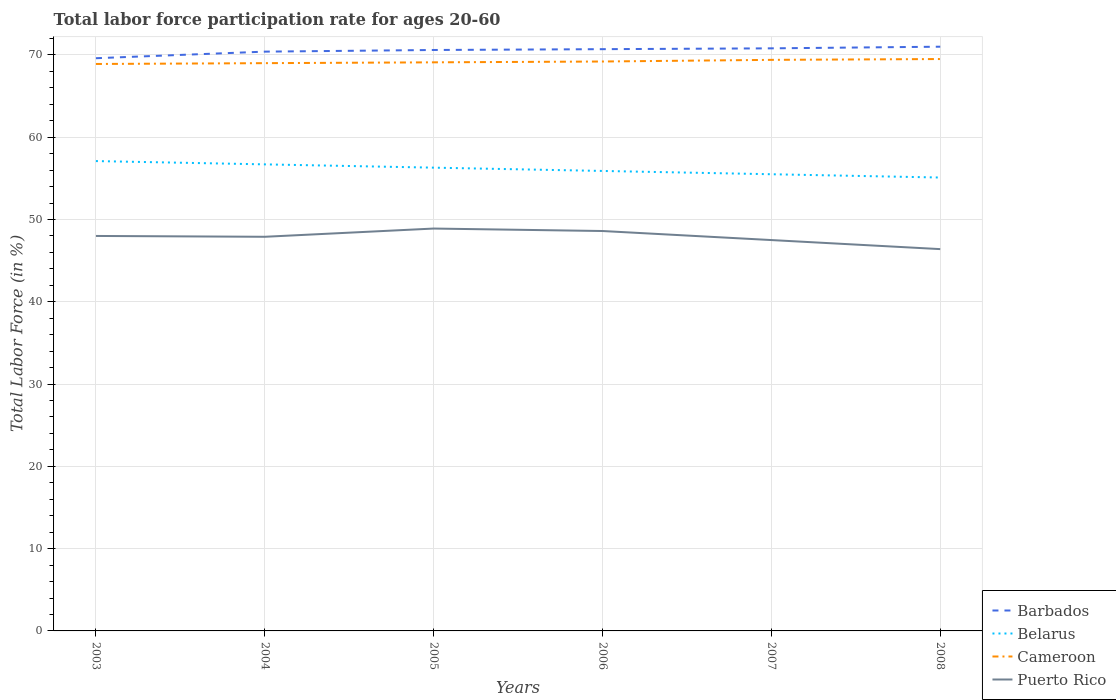Does the line corresponding to Cameroon intersect with the line corresponding to Belarus?
Provide a succinct answer. No. Is the number of lines equal to the number of legend labels?
Keep it short and to the point. Yes. Across all years, what is the maximum labor force participation rate in Belarus?
Offer a terse response. 55.1. What is the total labor force participation rate in Barbados in the graph?
Your response must be concise. -0.2. What is the difference between the highest and the second highest labor force participation rate in Belarus?
Your response must be concise. 2. What is the difference between the highest and the lowest labor force participation rate in Puerto Rico?
Provide a short and direct response. 4. What is the difference between two consecutive major ticks on the Y-axis?
Provide a short and direct response. 10. Does the graph contain any zero values?
Provide a short and direct response. No. Does the graph contain grids?
Provide a succinct answer. Yes. Where does the legend appear in the graph?
Your answer should be compact. Bottom right. How many legend labels are there?
Offer a terse response. 4. How are the legend labels stacked?
Give a very brief answer. Vertical. What is the title of the graph?
Ensure brevity in your answer.  Total labor force participation rate for ages 20-60. Does "High income" appear as one of the legend labels in the graph?
Your response must be concise. No. What is the label or title of the X-axis?
Give a very brief answer. Years. What is the label or title of the Y-axis?
Offer a very short reply. Total Labor Force (in %). What is the Total Labor Force (in %) of Barbados in 2003?
Your response must be concise. 69.6. What is the Total Labor Force (in %) of Belarus in 2003?
Provide a succinct answer. 57.1. What is the Total Labor Force (in %) of Cameroon in 2003?
Ensure brevity in your answer.  68.9. What is the Total Labor Force (in %) in Barbados in 2004?
Ensure brevity in your answer.  70.4. What is the Total Labor Force (in %) of Belarus in 2004?
Your answer should be compact. 56.7. What is the Total Labor Force (in %) of Puerto Rico in 2004?
Your answer should be very brief. 47.9. What is the Total Labor Force (in %) of Barbados in 2005?
Your answer should be very brief. 70.6. What is the Total Labor Force (in %) in Belarus in 2005?
Offer a terse response. 56.3. What is the Total Labor Force (in %) in Cameroon in 2005?
Your answer should be compact. 69.1. What is the Total Labor Force (in %) of Puerto Rico in 2005?
Ensure brevity in your answer.  48.9. What is the Total Labor Force (in %) of Barbados in 2006?
Ensure brevity in your answer.  70.7. What is the Total Labor Force (in %) in Belarus in 2006?
Make the answer very short. 55.9. What is the Total Labor Force (in %) of Cameroon in 2006?
Provide a succinct answer. 69.2. What is the Total Labor Force (in %) in Puerto Rico in 2006?
Your answer should be compact. 48.6. What is the Total Labor Force (in %) in Barbados in 2007?
Provide a short and direct response. 70.8. What is the Total Labor Force (in %) of Belarus in 2007?
Make the answer very short. 55.5. What is the Total Labor Force (in %) of Cameroon in 2007?
Provide a short and direct response. 69.4. What is the Total Labor Force (in %) of Puerto Rico in 2007?
Provide a succinct answer. 47.5. What is the Total Labor Force (in %) in Barbados in 2008?
Make the answer very short. 71. What is the Total Labor Force (in %) of Belarus in 2008?
Your response must be concise. 55.1. What is the Total Labor Force (in %) of Cameroon in 2008?
Provide a succinct answer. 69.5. What is the Total Labor Force (in %) in Puerto Rico in 2008?
Keep it short and to the point. 46.4. Across all years, what is the maximum Total Labor Force (in %) in Barbados?
Your response must be concise. 71. Across all years, what is the maximum Total Labor Force (in %) of Belarus?
Make the answer very short. 57.1. Across all years, what is the maximum Total Labor Force (in %) of Cameroon?
Provide a short and direct response. 69.5. Across all years, what is the maximum Total Labor Force (in %) of Puerto Rico?
Keep it short and to the point. 48.9. Across all years, what is the minimum Total Labor Force (in %) in Barbados?
Your response must be concise. 69.6. Across all years, what is the minimum Total Labor Force (in %) of Belarus?
Your answer should be compact. 55.1. Across all years, what is the minimum Total Labor Force (in %) in Cameroon?
Make the answer very short. 68.9. Across all years, what is the minimum Total Labor Force (in %) of Puerto Rico?
Give a very brief answer. 46.4. What is the total Total Labor Force (in %) in Barbados in the graph?
Keep it short and to the point. 423.1. What is the total Total Labor Force (in %) in Belarus in the graph?
Provide a succinct answer. 336.6. What is the total Total Labor Force (in %) in Cameroon in the graph?
Make the answer very short. 415.1. What is the total Total Labor Force (in %) of Puerto Rico in the graph?
Offer a very short reply. 287.3. What is the difference between the Total Labor Force (in %) in Cameroon in 2003 and that in 2004?
Ensure brevity in your answer.  -0.1. What is the difference between the Total Labor Force (in %) of Puerto Rico in 2003 and that in 2005?
Offer a very short reply. -0.9. What is the difference between the Total Labor Force (in %) of Belarus in 2003 and that in 2006?
Provide a short and direct response. 1.2. What is the difference between the Total Labor Force (in %) of Puerto Rico in 2003 and that in 2008?
Make the answer very short. 1.6. What is the difference between the Total Labor Force (in %) of Belarus in 2004 and that in 2005?
Offer a very short reply. 0.4. What is the difference between the Total Labor Force (in %) in Cameroon in 2004 and that in 2005?
Give a very brief answer. -0.1. What is the difference between the Total Labor Force (in %) in Puerto Rico in 2004 and that in 2005?
Make the answer very short. -1. What is the difference between the Total Labor Force (in %) in Belarus in 2004 and that in 2006?
Provide a short and direct response. 0.8. What is the difference between the Total Labor Force (in %) in Cameroon in 2004 and that in 2006?
Provide a succinct answer. -0.2. What is the difference between the Total Labor Force (in %) of Cameroon in 2004 and that in 2008?
Your answer should be very brief. -0.5. What is the difference between the Total Labor Force (in %) of Barbados in 2005 and that in 2006?
Your answer should be compact. -0.1. What is the difference between the Total Labor Force (in %) in Belarus in 2005 and that in 2006?
Make the answer very short. 0.4. What is the difference between the Total Labor Force (in %) in Puerto Rico in 2005 and that in 2006?
Provide a short and direct response. 0.3. What is the difference between the Total Labor Force (in %) of Barbados in 2005 and that in 2007?
Make the answer very short. -0.2. What is the difference between the Total Labor Force (in %) of Belarus in 2005 and that in 2007?
Your answer should be compact. 0.8. What is the difference between the Total Labor Force (in %) in Cameroon in 2005 and that in 2007?
Give a very brief answer. -0.3. What is the difference between the Total Labor Force (in %) of Barbados in 2005 and that in 2008?
Provide a short and direct response. -0.4. What is the difference between the Total Labor Force (in %) of Cameroon in 2005 and that in 2008?
Provide a succinct answer. -0.4. What is the difference between the Total Labor Force (in %) in Puerto Rico in 2005 and that in 2008?
Your response must be concise. 2.5. What is the difference between the Total Labor Force (in %) of Barbados in 2006 and that in 2007?
Ensure brevity in your answer.  -0.1. What is the difference between the Total Labor Force (in %) in Cameroon in 2006 and that in 2007?
Ensure brevity in your answer.  -0.2. What is the difference between the Total Labor Force (in %) in Belarus in 2006 and that in 2008?
Provide a succinct answer. 0.8. What is the difference between the Total Labor Force (in %) of Barbados in 2007 and that in 2008?
Give a very brief answer. -0.2. What is the difference between the Total Labor Force (in %) in Belarus in 2007 and that in 2008?
Offer a very short reply. 0.4. What is the difference between the Total Labor Force (in %) of Barbados in 2003 and the Total Labor Force (in %) of Belarus in 2004?
Your answer should be compact. 12.9. What is the difference between the Total Labor Force (in %) of Barbados in 2003 and the Total Labor Force (in %) of Puerto Rico in 2004?
Provide a short and direct response. 21.7. What is the difference between the Total Labor Force (in %) of Belarus in 2003 and the Total Labor Force (in %) of Cameroon in 2004?
Provide a short and direct response. -11.9. What is the difference between the Total Labor Force (in %) in Belarus in 2003 and the Total Labor Force (in %) in Puerto Rico in 2004?
Provide a succinct answer. 9.2. What is the difference between the Total Labor Force (in %) in Cameroon in 2003 and the Total Labor Force (in %) in Puerto Rico in 2004?
Provide a short and direct response. 21. What is the difference between the Total Labor Force (in %) of Barbados in 2003 and the Total Labor Force (in %) of Cameroon in 2005?
Offer a terse response. 0.5. What is the difference between the Total Labor Force (in %) of Barbados in 2003 and the Total Labor Force (in %) of Puerto Rico in 2005?
Provide a short and direct response. 20.7. What is the difference between the Total Labor Force (in %) of Belarus in 2003 and the Total Labor Force (in %) of Cameroon in 2005?
Make the answer very short. -12. What is the difference between the Total Labor Force (in %) in Cameroon in 2003 and the Total Labor Force (in %) in Puerto Rico in 2005?
Ensure brevity in your answer.  20. What is the difference between the Total Labor Force (in %) in Belarus in 2003 and the Total Labor Force (in %) in Cameroon in 2006?
Provide a short and direct response. -12.1. What is the difference between the Total Labor Force (in %) in Cameroon in 2003 and the Total Labor Force (in %) in Puerto Rico in 2006?
Your response must be concise. 20.3. What is the difference between the Total Labor Force (in %) of Barbados in 2003 and the Total Labor Force (in %) of Belarus in 2007?
Your answer should be very brief. 14.1. What is the difference between the Total Labor Force (in %) of Barbados in 2003 and the Total Labor Force (in %) of Cameroon in 2007?
Your answer should be compact. 0.2. What is the difference between the Total Labor Force (in %) of Barbados in 2003 and the Total Labor Force (in %) of Puerto Rico in 2007?
Ensure brevity in your answer.  22.1. What is the difference between the Total Labor Force (in %) of Belarus in 2003 and the Total Labor Force (in %) of Cameroon in 2007?
Provide a succinct answer. -12.3. What is the difference between the Total Labor Force (in %) in Cameroon in 2003 and the Total Labor Force (in %) in Puerto Rico in 2007?
Provide a succinct answer. 21.4. What is the difference between the Total Labor Force (in %) of Barbados in 2003 and the Total Labor Force (in %) of Cameroon in 2008?
Offer a terse response. 0.1. What is the difference between the Total Labor Force (in %) of Barbados in 2003 and the Total Labor Force (in %) of Puerto Rico in 2008?
Ensure brevity in your answer.  23.2. What is the difference between the Total Labor Force (in %) in Belarus in 2003 and the Total Labor Force (in %) in Puerto Rico in 2008?
Offer a very short reply. 10.7. What is the difference between the Total Labor Force (in %) of Barbados in 2004 and the Total Labor Force (in %) of Belarus in 2005?
Make the answer very short. 14.1. What is the difference between the Total Labor Force (in %) of Barbados in 2004 and the Total Labor Force (in %) of Puerto Rico in 2005?
Your response must be concise. 21.5. What is the difference between the Total Labor Force (in %) in Belarus in 2004 and the Total Labor Force (in %) in Cameroon in 2005?
Ensure brevity in your answer.  -12.4. What is the difference between the Total Labor Force (in %) of Cameroon in 2004 and the Total Labor Force (in %) of Puerto Rico in 2005?
Provide a succinct answer. 20.1. What is the difference between the Total Labor Force (in %) of Barbados in 2004 and the Total Labor Force (in %) of Belarus in 2006?
Make the answer very short. 14.5. What is the difference between the Total Labor Force (in %) in Barbados in 2004 and the Total Labor Force (in %) in Cameroon in 2006?
Your response must be concise. 1.2. What is the difference between the Total Labor Force (in %) in Barbados in 2004 and the Total Labor Force (in %) in Puerto Rico in 2006?
Offer a very short reply. 21.8. What is the difference between the Total Labor Force (in %) in Belarus in 2004 and the Total Labor Force (in %) in Puerto Rico in 2006?
Provide a succinct answer. 8.1. What is the difference between the Total Labor Force (in %) in Cameroon in 2004 and the Total Labor Force (in %) in Puerto Rico in 2006?
Make the answer very short. 20.4. What is the difference between the Total Labor Force (in %) of Barbados in 2004 and the Total Labor Force (in %) of Belarus in 2007?
Offer a very short reply. 14.9. What is the difference between the Total Labor Force (in %) of Barbados in 2004 and the Total Labor Force (in %) of Cameroon in 2007?
Provide a short and direct response. 1. What is the difference between the Total Labor Force (in %) of Barbados in 2004 and the Total Labor Force (in %) of Puerto Rico in 2007?
Provide a succinct answer. 22.9. What is the difference between the Total Labor Force (in %) of Belarus in 2004 and the Total Labor Force (in %) of Cameroon in 2007?
Your answer should be very brief. -12.7. What is the difference between the Total Labor Force (in %) in Belarus in 2004 and the Total Labor Force (in %) in Puerto Rico in 2007?
Make the answer very short. 9.2. What is the difference between the Total Labor Force (in %) of Cameroon in 2004 and the Total Labor Force (in %) of Puerto Rico in 2007?
Offer a very short reply. 21.5. What is the difference between the Total Labor Force (in %) in Barbados in 2004 and the Total Labor Force (in %) in Puerto Rico in 2008?
Give a very brief answer. 24. What is the difference between the Total Labor Force (in %) in Cameroon in 2004 and the Total Labor Force (in %) in Puerto Rico in 2008?
Make the answer very short. 22.6. What is the difference between the Total Labor Force (in %) of Barbados in 2005 and the Total Labor Force (in %) of Cameroon in 2006?
Your answer should be compact. 1.4. What is the difference between the Total Labor Force (in %) of Belarus in 2005 and the Total Labor Force (in %) of Cameroon in 2006?
Your response must be concise. -12.9. What is the difference between the Total Labor Force (in %) of Belarus in 2005 and the Total Labor Force (in %) of Puerto Rico in 2006?
Give a very brief answer. 7.7. What is the difference between the Total Labor Force (in %) of Barbados in 2005 and the Total Labor Force (in %) of Belarus in 2007?
Offer a very short reply. 15.1. What is the difference between the Total Labor Force (in %) of Barbados in 2005 and the Total Labor Force (in %) of Cameroon in 2007?
Your response must be concise. 1.2. What is the difference between the Total Labor Force (in %) of Barbados in 2005 and the Total Labor Force (in %) of Puerto Rico in 2007?
Offer a terse response. 23.1. What is the difference between the Total Labor Force (in %) of Cameroon in 2005 and the Total Labor Force (in %) of Puerto Rico in 2007?
Provide a short and direct response. 21.6. What is the difference between the Total Labor Force (in %) of Barbados in 2005 and the Total Labor Force (in %) of Belarus in 2008?
Your response must be concise. 15.5. What is the difference between the Total Labor Force (in %) of Barbados in 2005 and the Total Labor Force (in %) of Cameroon in 2008?
Make the answer very short. 1.1. What is the difference between the Total Labor Force (in %) in Barbados in 2005 and the Total Labor Force (in %) in Puerto Rico in 2008?
Make the answer very short. 24.2. What is the difference between the Total Labor Force (in %) of Belarus in 2005 and the Total Labor Force (in %) of Cameroon in 2008?
Your answer should be very brief. -13.2. What is the difference between the Total Labor Force (in %) of Cameroon in 2005 and the Total Labor Force (in %) of Puerto Rico in 2008?
Offer a very short reply. 22.7. What is the difference between the Total Labor Force (in %) of Barbados in 2006 and the Total Labor Force (in %) of Puerto Rico in 2007?
Your response must be concise. 23.2. What is the difference between the Total Labor Force (in %) of Belarus in 2006 and the Total Labor Force (in %) of Puerto Rico in 2007?
Offer a terse response. 8.4. What is the difference between the Total Labor Force (in %) in Cameroon in 2006 and the Total Labor Force (in %) in Puerto Rico in 2007?
Offer a terse response. 21.7. What is the difference between the Total Labor Force (in %) in Barbados in 2006 and the Total Labor Force (in %) in Belarus in 2008?
Provide a succinct answer. 15.6. What is the difference between the Total Labor Force (in %) in Barbados in 2006 and the Total Labor Force (in %) in Puerto Rico in 2008?
Offer a very short reply. 24.3. What is the difference between the Total Labor Force (in %) in Belarus in 2006 and the Total Labor Force (in %) in Cameroon in 2008?
Give a very brief answer. -13.6. What is the difference between the Total Labor Force (in %) of Belarus in 2006 and the Total Labor Force (in %) of Puerto Rico in 2008?
Your answer should be very brief. 9.5. What is the difference between the Total Labor Force (in %) in Cameroon in 2006 and the Total Labor Force (in %) in Puerto Rico in 2008?
Provide a short and direct response. 22.8. What is the difference between the Total Labor Force (in %) in Barbados in 2007 and the Total Labor Force (in %) in Belarus in 2008?
Provide a short and direct response. 15.7. What is the difference between the Total Labor Force (in %) of Barbados in 2007 and the Total Labor Force (in %) of Puerto Rico in 2008?
Ensure brevity in your answer.  24.4. What is the difference between the Total Labor Force (in %) of Belarus in 2007 and the Total Labor Force (in %) of Puerto Rico in 2008?
Offer a terse response. 9.1. What is the average Total Labor Force (in %) in Barbados per year?
Your response must be concise. 70.52. What is the average Total Labor Force (in %) of Belarus per year?
Ensure brevity in your answer.  56.1. What is the average Total Labor Force (in %) in Cameroon per year?
Your response must be concise. 69.18. What is the average Total Labor Force (in %) in Puerto Rico per year?
Offer a terse response. 47.88. In the year 2003, what is the difference between the Total Labor Force (in %) of Barbados and Total Labor Force (in %) of Cameroon?
Offer a terse response. 0.7. In the year 2003, what is the difference between the Total Labor Force (in %) in Barbados and Total Labor Force (in %) in Puerto Rico?
Offer a very short reply. 21.6. In the year 2003, what is the difference between the Total Labor Force (in %) of Belarus and Total Labor Force (in %) of Cameroon?
Your response must be concise. -11.8. In the year 2003, what is the difference between the Total Labor Force (in %) of Cameroon and Total Labor Force (in %) of Puerto Rico?
Provide a short and direct response. 20.9. In the year 2004, what is the difference between the Total Labor Force (in %) of Barbados and Total Labor Force (in %) of Belarus?
Offer a very short reply. 13.7. In the year 2004, what is the difference between the Total Labor Force (in %) of Barbados and Total Labor Force (in %) of Cameroon?
Give a very brief answer. 1.4. In the year 2004, what is the difference between the Total Labor Force (in %) of Belarus and Total Labor Force (in %) of Puerto Rico?
Provide a succinct answer. 8.8. In the year 2004, what is the difference between the Total Labor Force (in %) in Cameroon and Total Labor Force (in %) in Puerto Rico?
Offer a terse response. 21.1. In the year 2005, what is the difference between the Total Labor Force (in %) in Barbados and Total Labor Force (in %) in Belarus?
Ensure brevity in your answer.  14.3. In the year 2005, what is the difference between the Total Labor Force (in %) in Barbados and Total Labor Force (in %) in Cameroon?
Ensure brevity in your answer.  1.5. In the year 2005, what is the difference between the Total Labor Force (in %) in Barbados and Total Labor Force (in %) in Puerto Rico?
Keep it short and to the point. 21.7. In the year 2005, what is the difference between the Total Labor Force (in %) in Cameroon and Total Labor Force (in %) in Puerto Rico?
Give a very brief answer. 20.2. In the year 2006, what is the difference between the Total Labor Force (in %) of Barbados and Total Labor Force (in %) of Belarus?
Your answer should be very brief. 14.8. In the year 2006, what is the difference between the Total Labor Force (in %) in Barbados and Total Labor Force (in %) in Cameroon?
Your answer should be very brief. 1.5. In the year 2006, what is the difference between the Total Labor Force (in %) of Barbados and Total Labor Force (in %) of Puerto Rico?
Your answer should be compact. 22.1. In the year 2006, what is the difference between the Total Labor Force (in %) in Belarus and Total Labor Force (in %) in Puerto Rico?
Keep it short and to the point. 7.3. In the year 2006, what is the difference between the Total Labor Force (in %) of Cameroon and Total Labor Force (in %) of Puerto Rico?
Your response must be concise. 20.6. In the year 2007, what is the difference between the Total Labor Force (in %) of Barbados and Total Labor Force (in %) of Belarus?
Give a very brief answer. 15.3. In the year 2007, what is the difference between the Total Labor Force (in %) of Barbados and Total Labor Force (in %) of Cameroon?
Ensure brevity in your answer.  1.4. In the year 2007, what is the difference between the Total Labor Force (in %) of Barbados and Total Labor Force (in %) of Puerto Rico?
Offer a terse response. 23.3. In the year 2007, what is the difference between the Total Labor Force (in %) of Belarus and Total Labor Force (in %) of Cameroon?
Offer a terse response. -13.9. In the year 2007, what is the difference between the Total Labor Force (in %) of Cameroon and Total Labor Force (in %) of Puerto Rico?
Offer a very short reply. 21.9. In the year 2008, what is the difference between the Total Labor Force (in %) of Barbados and Total Labor Force (in %) of Cameroon?
Provide a succinct answer. 1.5. In the year 2008, what is the difference between the Total Labor Force (in %) of Barbados and Total Labor Force (in %) of Puerto Rico?
Provide a short and direct response. 24.6. In the year 2008, what is the difference between the Total Labor Force (in %) in Belarus and Total Labor Force (in %) in Cameroon?
Make the answer very short. -14.4. In the year 2008, what is the difference between the Total Labor Force (in %) of Belarus and Total Labor Force (in %) of Puerto Rico?
Provide a succinct answer. 8.7. In the year 2008, what is the difference between the Total Labor Force (in %) of Cameroon and Total Labor Force (in %) of Puerto Rico?
Your answer should be very brief. 23.1. What is the ratio of the Total Labor Force (in %) of Belarus in 2003 to that in 2004?
Your answer should be very brief. 1.01. What is the ratio of the Total Labor Force (in %) in Cameroon in 2003 to that in 2004?
Your response must be concise. 1. What is the ratio of the Total Labor Force (in %) in Barbados in 2003 to that in 2005?
Ensure brevity in your answer.  0.99. What is the ratio of the Total Labor Force (in %) in Belarus in 2003 to that in 2005?
Make the answer very short. 1.01. What is the ratio of the Total Labor Force (in %) of Cameroon in 2003 to that in 2005?
Give a very brief answer. 1. What is the ratio of the Total Labor Force (in %) in Puerto Rico in 2003 to that in 2005?
Offer a very short reply. 0.98. What is the ratio of the Total Labor Force (in %) of Barbados in 2003 to that in 2006?
Ensure brevity in your answer.  0.98. What is the ratio of the Total Labor Force (in %) of Belarus in 2003 to that in 2006?
Give a very brief answer. 1.02. What is the ratio of the Total Labor Force (in %) in Barbados in 2003 to that in 2007?
Give a very brief answer. 0.98. What is the ratio of the Total Labor Force (in %) of Belarus in 2003 to that in 2007?
Your answer should be very brief. 1.03. What is the ratio of the Total Labor Force (in %) of Cameroon in 2003 to that in 2007?
Your response must be concise. 0.99. What is the ratio of the Total Labor Force (in %) of Puerto Rico in 2003 to that in 2007?
Offer a terse response. 1.01. What is the ratio of the Total Labor Force (in %) in Barbados in 2003 to that in 2008?
Your response must be concise. 0.98. What is the ratio of the Total Labor Force (in %) of Belarus in 2003 to that in 2008?
Your answer should be compact. 1.04. What is the ratio of the Total Labor Force (in %) in Cameroon in 2003 to that in 2008?
Your answer should be very brief. 0.99. What is the ratio of the Total Labor Force (in %) of Puerto Rico in 2003 to that in 2008?
Offer a terse response. 1.03. What is the ratio of the Total Labor Force (in %) in Belarus in 2004 to that in 2005?
Keep it short and to the point. 1.01. What is the ratio of the Total Labor Force (in %) of Puerto Rico in 2004 to that in 2005?
Offer a terse response. 0.98. What is the ratio of the Total Labor Force (in %) in Belarus in 2004 to that in 2006?
Your answer should be compact. 1.01. What is the ratio of the Total Labor Force (in %) in Cameroon in 2004 to that in 2006?
Make the answer very short. 1. What is the ratio of the Total Labor Force (in %) of Puerto Rico in 2004 to that in 2006?
Keep it short and to the point. 0.99. What is the ratio of the Total Labor Force (in %) of Barbados in 2004 to that in 2007?
Provide a short and direct response. 0.99. What is the ratio of the Total Labor Force (in %) of Belarus in 2004 to that in 2007?
Provide a short and direct response. 1.02. What is the ratio of the Total Labor Force (in %) in Puerto Rico in 2004 to that in 2007?
Provide a short and direct response. 1.01. What is the ratio of the Total Labor Force (in %) of Barbados in 2004 to that in 2008?
Make the answer very short. 0.99. What is the ratio of the Total Labor Force (in %) of Cameroon in 2004 to that in 2008?
Offer a terse response. 0.99. What is the ratio of the Total Labor Force (in %) in Puerto Rico in 2004 to that in 2008?
Give a very brief answer. 1.03. What is the ratio of the Total Labor Force (in %) of Belarus in 2005 to that in 2006?
Keep it short and to the point. 1.01. What is the ratio of the Total Labor Force (in %) in Cameroon in 2005 to that in 2006?
Offer a very short reply. 1. What is the ratio of the Total Labor Force (in %) of Belarus in 2005 to that in 2007?
Ensure brevity in your answer.  1.01. What is the ratio of the Total Labor Force (in %) of Puerto Rico in 2005 to that in 2007?
Ensure brevity in your answer.  1.03. What is the ratio of the Total Labor Force (in %) of Belarus in 2005 to that in 2008?
Offer a terse response. 1.02. What is the ratio of the Total Labor Force (in %) of Cameroon in 2005 to that in 2008?
Make the answer very short. 0.99. What is the ratio of the Total Labor Force (in %) in Puerto Rico in 2005 to that in 2008?
Make the answer very short. 1.05. What is the ratio of the Total Labor Force (in %) in Barbados in 2006 to that in 2007?
Offer a very short reply. 1. What is the ratio of the Total Labor Force (in %) of Puerto Rico in 2006 to that in 2007?
Give a very brief answer. 1.02. What is the ratio of the Total Labor Force (in %) in Belarus in 2006 to that in 2008?
Offer a terse response. 1.01. What is the ratio of the Total Labor Force (in %) in Cameroon in 2006 to that in 2008?
Your answer should be very brief. 1. What is the ratio of the Total Labor Force (in %) of Puerto Rico in 2006 to that in 2008?
Give a very brief answer. 1.05. What is the ratio of the Total Labor Force (in %) in Belarus in 2007 to that in 2008?
Give a very brief answer. 1.01. What is the ratio of the Total Labor Force (in %) of Puerto Rico in 2007 to that in 2008?
Your answer should be very brief. 1.02. What is the difference between the highest and the second highest Total Labor Force (in %) of Barbados?
Offer a terse response. 0.2. What is the difference between the highest and the lowest Total Labor Force (in %) of Cameroon?
Your answer should be very brief. 0.6. 